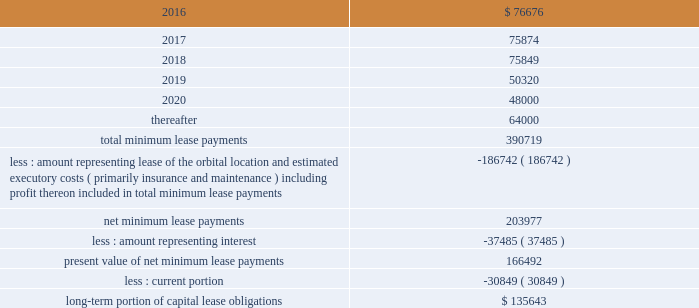Dish network corporation notes to consolidated financial statements - continued future minimum lease payments under the capital lease obligations , together with the present value of the net minimum lease payments as of december 31 , 2015 are as follows ( in thousands ) : for the years ended december 31 .
The summary of future maturities of our outstanding long-term debt as of december 31 , 2015 is included in the commitments table in note 15 .
11 .
Income taxes and accounting for uncertainty in income taxes income taxes our income tax policy is to record the estimated future tax effects of temporary differences between the tax bases of assets and liabilities and amounts reported on our consolidated balance sheets , as well as probable operating loss , tax credit and other carryforwards .
Deferred tax assets are offset by valuation allowances when we believe it is more likely than not that net deferred tax assets will not be realized .
We periodically evaluate our need for a valuation allowance .
Determining necessary valuation allowances requires us to make assessments about historical financial information as well as the timing of future events , including the probability of expected future taxable income and available tax planning opportunities .
We file consolidated tax returns in the u.s .
The income taxes of domestic and foreign subsidiaries not included in the u.s .
Tax group are presented in our consolidated financial statements on a separate return basis for each tax paying entity .
As of december 31 , 2015 , we had no net operating loss carryforwards ( 201cnols 201d ) for federal income tax purposes and $ 39 million of nol benefit for state income tax purposes , which are partially offset by a valuation allowance .
The state nols begin to expire in the year 2017 .
In addition , there are $ 61 million of tax benefits related to credit carryforwards which are partially offset by a valuation allowance .
The state credit carryforwards began to expire in .
What percentage of future minimum lease payments under the capital lease obligations is due in 2020? 
Computations: (48000 / 390719)
Answer: 0.12285. 